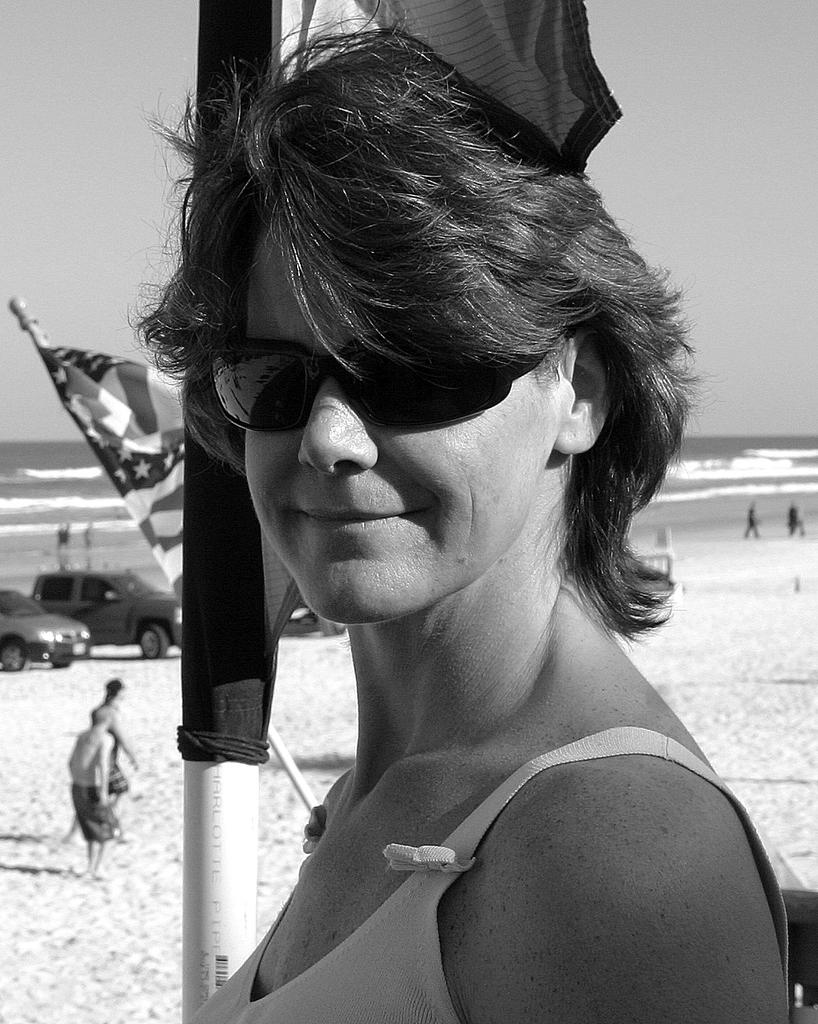Who is present in the image? There is a woman in the image. What is the woman doing in the image? The woman is smiling in the image. What is the woman wearing on her head? The woman is wearing goggles in the image. What can be seen in the background of the image? There are flags and a pole, water, and the sky visible in the background. What is happening in the distance on the sand? People are visible in the distance on the sand, and vehicles are present there as well. What type of education can be seen in the image? There is no reference to education in the image; it features a woman wearing goggles, flags, people, and vehicles on the sand. What is the fang doing in the image? There is no fang present in the image. 